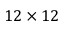<formula> <loc_0><loc_0><loc_500><loc_500>1 2 \times 1 2</formula> 